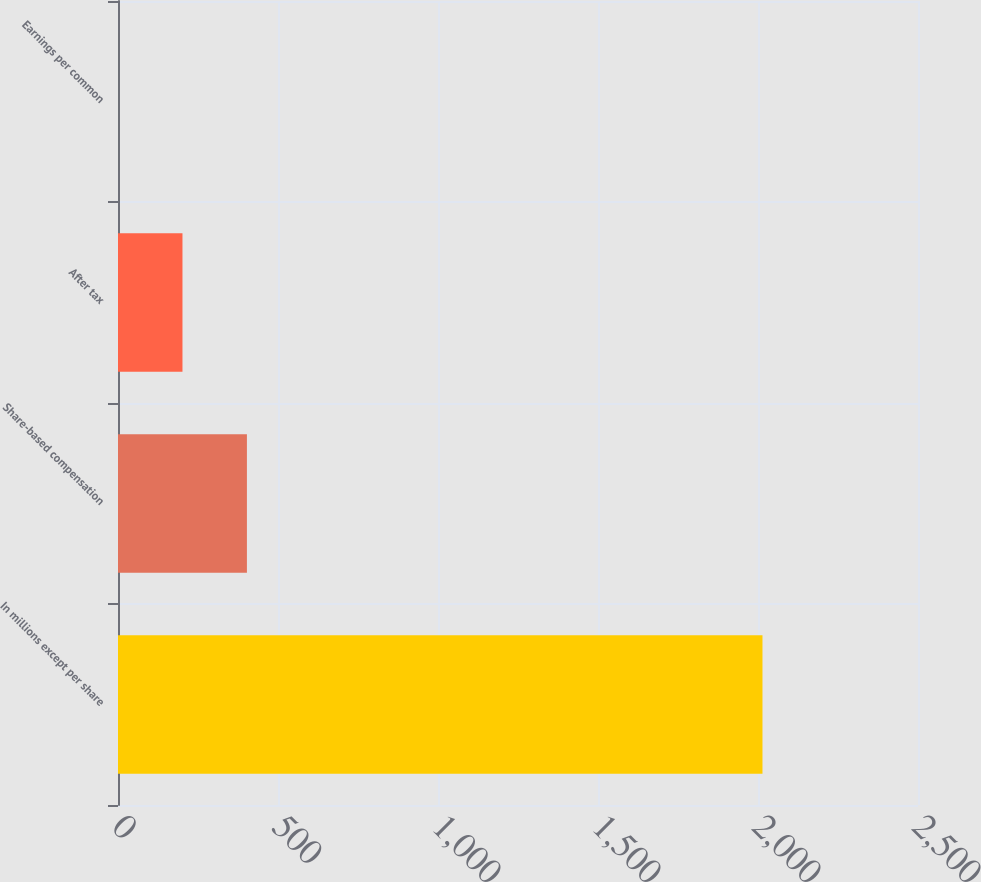<chart> <loc_0><loc_0><loc_500><loc_500><bar_chart><fcel>In millions except per share<fcel>Share-based compensation<fcel>After tax<fcel>Earnings per common<nl><fcel>2014<fcel>402.86<fcel>201.47<fcel>0.08<nl></chart> 